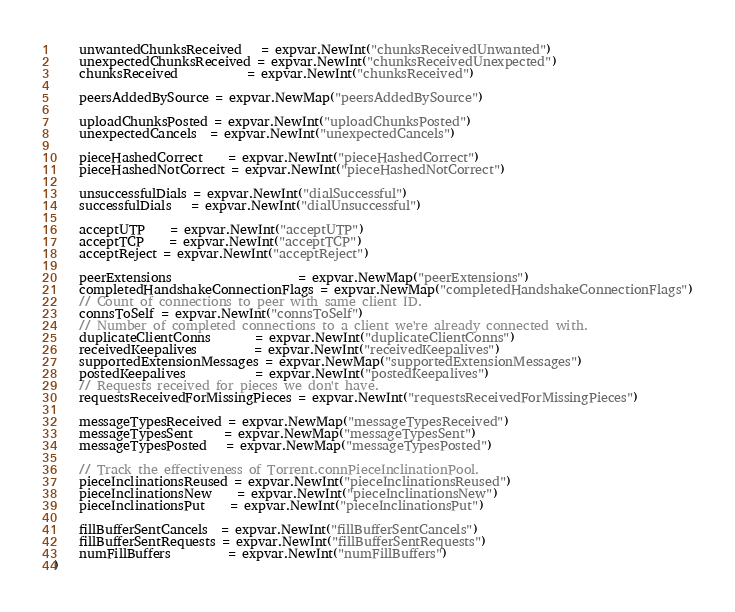Convert code to text. <code><loc_0><loc_0><loc_500><loc_500><_Go_>	unwantedChunksReceived   = expvar.NewInt("chunksReceivedUnwanted")
	unexpectedChunksReceived = expvar.NewInt("chunksReceivedUnexpected")
	chunksReceived           = expvar.NewInt("chunksReceived")

	peersAddedBySource = expvar.NewMap("peersAddedBySource")

	uploadChunksPosted = expvar.NewInt("uploadChunksPosted")
	unexpectedCancels  = expvar.NewInt("unexpectedCancels")

	pieceHashedCorrect    = expvar.NewInt("pieceHashedCorrect")
	pieceHashedNotCorrect = expvar.NewInt("pieceHashedNotCorrect")

	unsuccessfulDials = expvar.NewInt("dialSuccessful")
	successfulDials   = expvar.NewInt("dialUnsuccessful")

	acceptUTP    = expvar.NewInt("acceptUTP")
	acceptTCP    = expvar.NewInt("acceptTCP")
	acceptReject = expvar.NewInt("acceptReject")

	peerExtensions                    = expvar.NewMap("peerExtensions")
	completedHandshakeConnectionFlags = expvar.NewMap("completedHandshakeConnectionFlags")
	// Count of connections to peer with same client ID.
	connsToSelf = expvar.NewInt("connsToSelf")
	// Number of completed connections to a client we're already connected with.
	duplicateClientConns       = expvar.NewInt("duplicateClientConns")
	receivedKeepalives         = expvar.NewInt("receivedKeepalives")
	supportedExtensionMessages = expvar.NewMap("supportedExtensionMessages")
	postedKeepalives           = expvar.NewInt("postedKeepalives")
	// Requests received for pieces we don't have.
	requestsReceivedForMissingPieces = expvar.NewInt("requestsReceivedForMissingPieces")

	messageTypesReceived = expvar.NewMap("messageTypesReceived")
	messageTypesSent     = expvar.NewMap("messageTypesSent")
	messageTypesPosted   = expvar.NewMap("messageTypesPosted")

	// Track the effectiveness of Torrent.connPieceInclinationPool.
	pieceInclinationsReused = expvar.NewInt("pieceInclinationsReused")
	pieceInclinationsNew    = expvar.NewInt("pieceInclinationsNew")
	pieceInclinationsPut    = expvar.NewInt("pieceInclinationsPut")

	fillBufferSentCancels  = expvar.NewInt("fillBufferSentCancels")
	fillBufferSentRequests = expvar.NewInt("fillBufferSentRequests")
	numFillBuffers         = expvar.NewInt("numFillBuffers")
)
</code> 